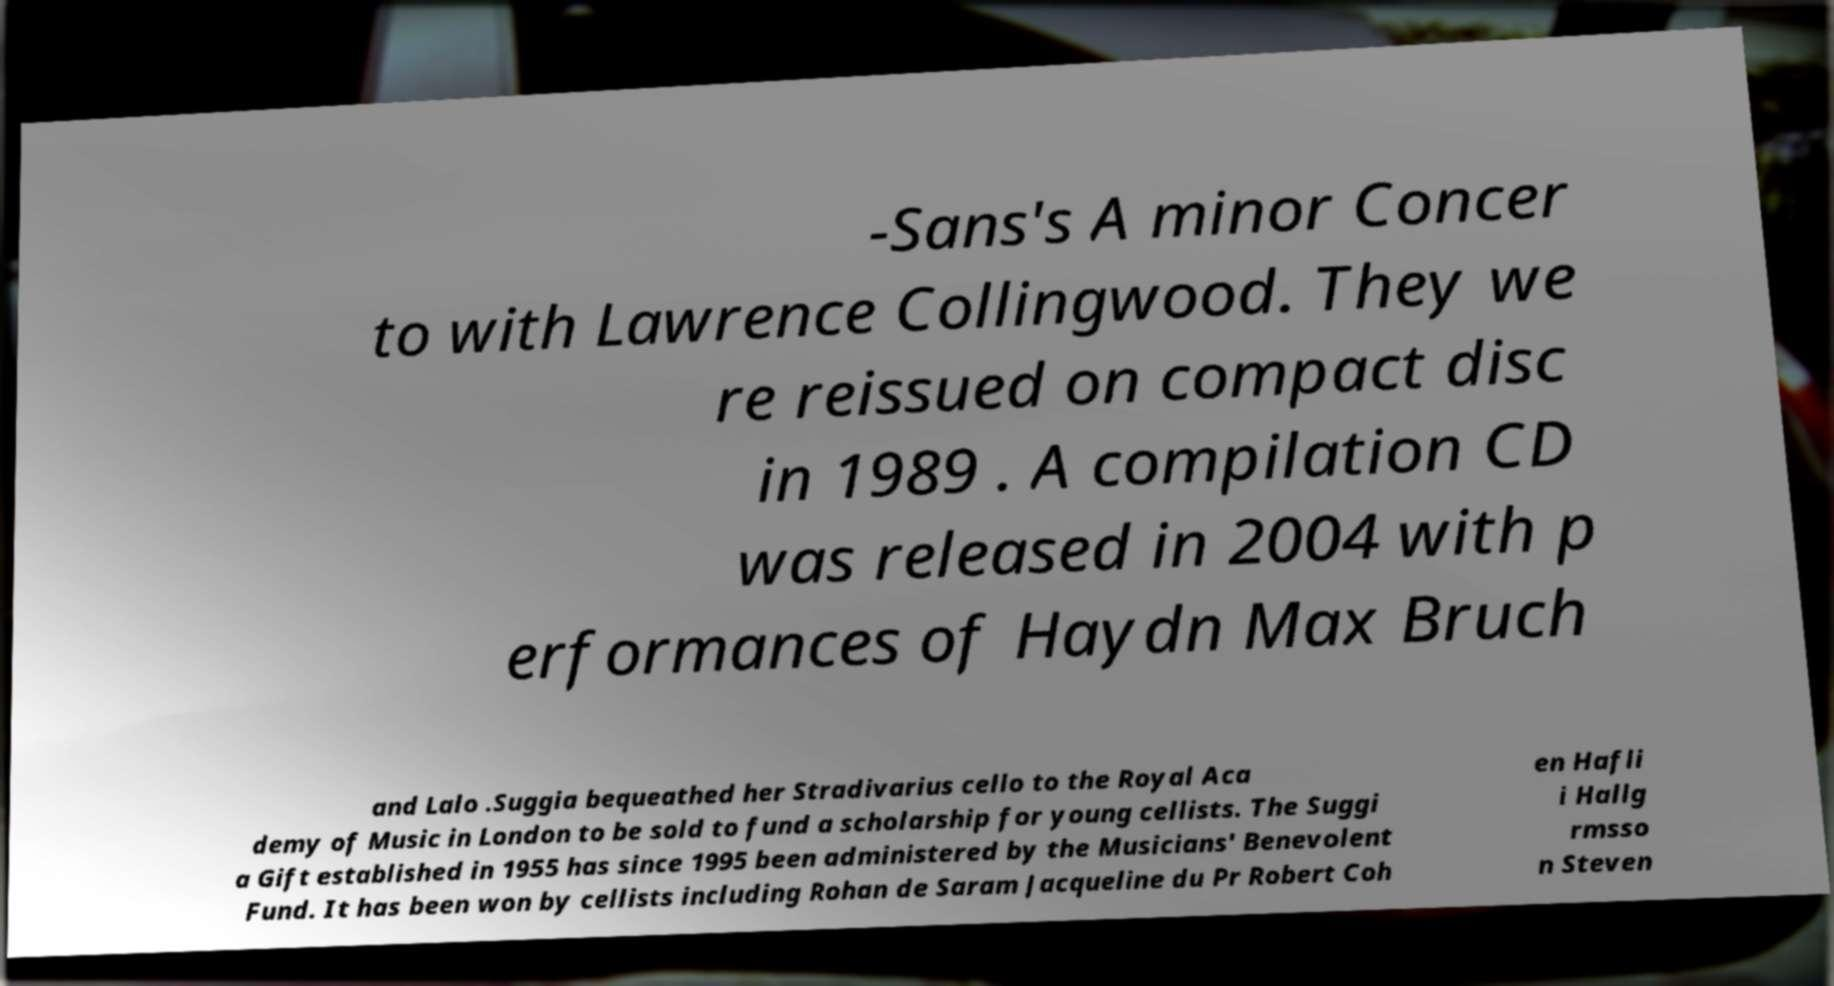For documentation purposes, I need the text within this image transcribed. Could you provide that? -Sans's A minor Concer to with Lawrence Collingwood. They we re reissued on compact disc in 1989 . A compilation CD was released in 2004 with p erformances of Haydn Max Bruch and Lalo .Suggia bequeathed her Stradivarius cello to the Royal Aca demy of Music in London to be sold to fund a scholarship for young cellists. The Suggi a Gift established in 1955 has since 1995 been administered by the Musicians' Benevolent Fund. It has been won by cellists including Rohan de Saram Jacqueline du Pr Robert Coh en Hafli i Hallg rmsso n Steven 